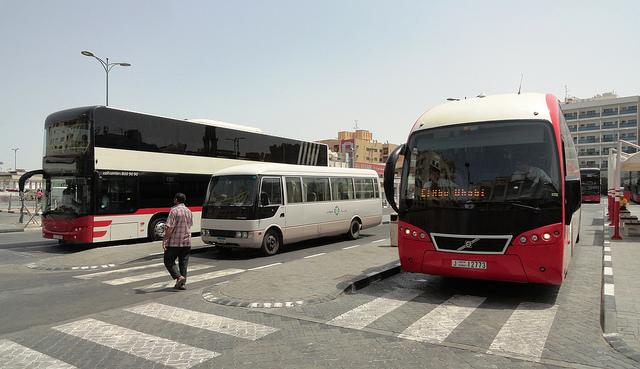Is the pedestrian wearing clothes?
Concise answer only. Yes. Which bus is the smallest?
Keep it brief. Middle. What color is the bus in the middle?
Quick response, please. White. 